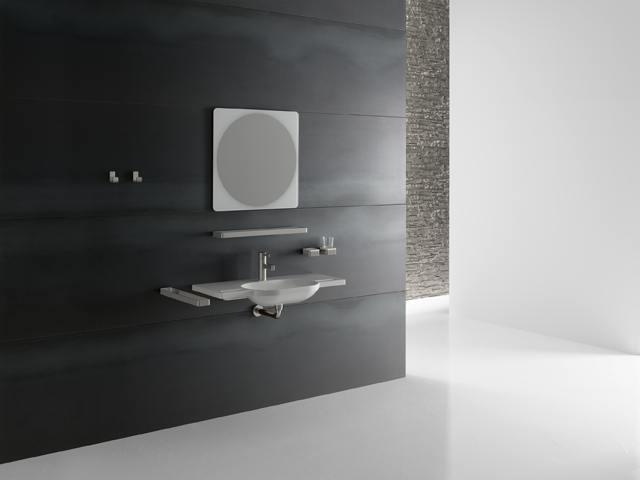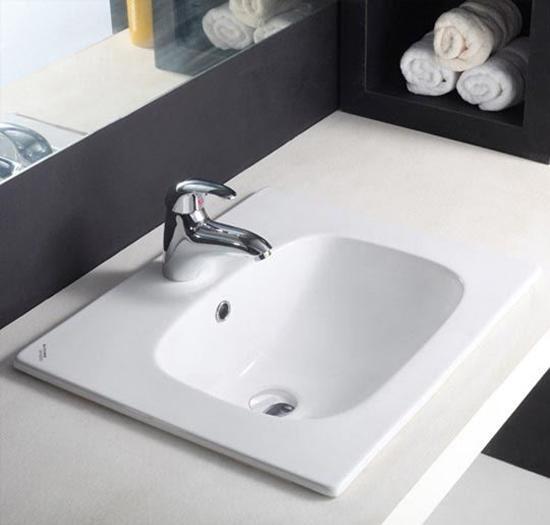The first image is the image on the left, the second image is the image on the right. For the images shown, is this caption "All sinks shown mount to the wall and have a rounded inset basin without a separate counter." true? Answer yes or no. No. 